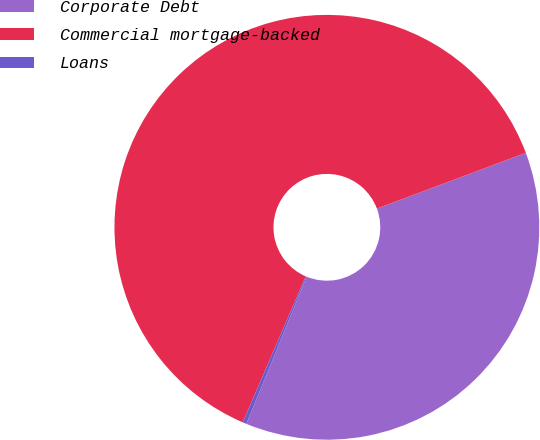Convert chart to OTSL. <chart><loc_0><loc_0><loc_500><loc_500><pie_chart><fcel>Corporate Debt<fcel>Commercial mortgage-backed<fcel>Loans<nl><fcel>36.89%<fcel>62.82%<fcel>0.29%<nl></chart> 